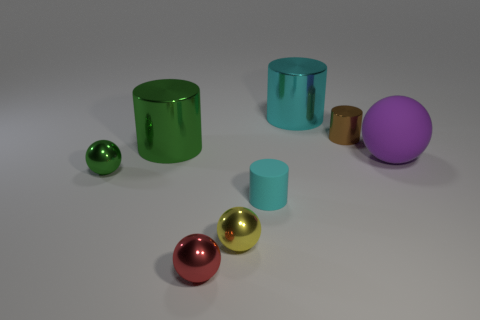Are there more brown metal cylinders to the left of the red shiny sphere than red matte cubes?
Your answer should be very brief. No. What is the material of the object that is behind the green metallic cylinder and to the right of the large cyan shiny cylinder?
Provide a succinct answer. Metal. Is there any other thing that has the same shape as the tiny brown metal thing?
Give a very brief answer. Yes. What number of tiny spheres are both on the right side of the tiny green thing and behind the tiny red shiny thing?
Offer a terse response. 1. Is the number of small yellow metal objects the same as the number of matte things?
Your answer should be very brief. No. What material is the large purple ball?
Make the answer very short. Rubber. Are there an equal number of large cyan metallic objects that are in front of the red sphere and cyan rubber cylinders?
Ensure brevity in your answer.  No. How many small cyan metallic things are the same shape as the big cyan metallic thing?
Offer a very short reply. 0. Is the shape of the purple rubber thing the same as the red metal thing?
Make the answer very short. Yes. What number of objects are objects that are in front of the big sphere or shiny things?
Your answer should be very brief. 7. 